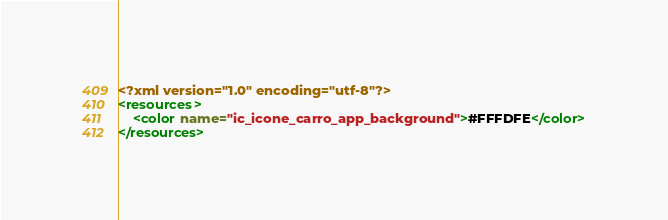<code> <loc_0><loc_0><loc_500><loc_500><_XML_><?xml version="1.0" encoding="utf-8"?>
<resources>
    <color name="ic_icone_carro_app_background">#FFFDFE</color>
</resources></code> 